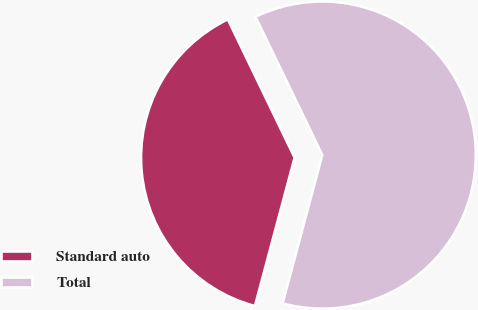Convert chart. <chart><loc_0><loc_0><loc_500><loc_500><pie_chart><fcel>Standard auto<fcel>Total<nl><fcel>38.68%<fcel>61.32%<nl></chart> 